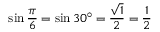Convert formula to latex. <formula><loc_0><loc_0><loc_500><loc_500>\sin { \frac { \pi } { 6 } } = \sin 3 0 ^ { \circ } = { \frac { \sqrt { 1 } } { 2 } } = { \frac { 1 } { 2 } }</formula> 